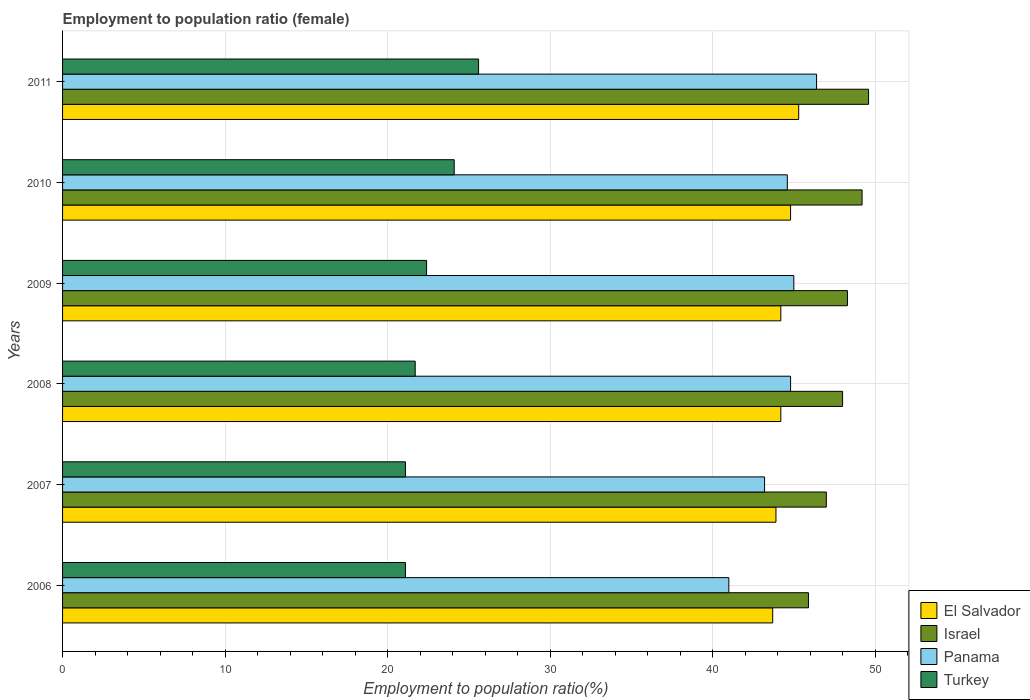How many different coloured bars are there?
Your answer should be compact. 4. Are the number of bars per tick equal to the number of legend labels?
Offer a terse response. Yes. Are the number of bars on each tick of the Y-axis equal?
Your answer should be compact. Yes. How many bars are there on the 4th tick from the top?
Offer a very short reply. 4. How many bars are there on the 3rd tick from the bottom?
Your response must be concise. 4. What is the label of the 2nd group of bars from the top?
Ensure brevity in your answer.  2010. What is the employment to population ratio in El Salvador in 2010?
Make the answer very short. 44.8. Across all years, what is the maximum employment to population ratio in Israel?
Give a very brief answer. 49.6. Across all years, what is the minimum employment to population ratio in El Salvador?
Offer a very short reply. 43.7. In which year was the employment to population ratio in Turkey maximum?
Your response must be concise. 2011. In which year was the employment to population ratio in Turkey minimum?
Offer a very short reply. 2006. What is the total employment to population ratio in El Salvador in the graph?
Offer a very short reply. 266.1. What is the difference between the employment to population ratio in El Salvador in 2006 and that in 2010?
Offer a very short reply. -1.1. What is the difference between the employment to population ratio in El Salvador in 2006 and the employment to population ratio in Turkey in 2010?
Your answer should be very brief. 19.6. What is the average employment to population ratio in Panama per year?
Keep it short and to the point. 44.17. In the year 2011, what is the difference between the employment to population ratio in Turkey and employment to population ratio in El Salvador?
Offer a terse response. -19.7. In how many years, is the employment to population ratio in El Salvador greater than 10 %?
Provide a short and direct response. 6. What is the ratio of the employment to population ratio in Israel in 2006 to that in 2008?
Provide a succinct answer. 0.96. Is the difference between the employment to population ratio in Turkey in 2009 and 2011 greater than the difference between the employment to population ratio in El Salvador in 2009 and 2011?
Give a very brief answer. No. What is the difference between the highest and the lowest employment to population ratio in Panama?
Your answer should be compact. 5.4. Is it the case that in every year, the sum of the employment to population ratio in El Salvador and employment to population ratio in Turkey is greater than the sum of employment to population ratio in Israel and employment to population ratio in Panama?
Offer a very short reply. No. How many bars are there?
Your response must be concise. 24. Are all the bars in the graph horizontal?
Give a very brief answer. Yes. How many years are there in the graph?
Your answer should be very brief. 6. What is the difference between two consecutive major ticks on the X-axis?
Your answer should be compact. 10. How many legend labels are there?
Your answer should be very brief. 4. How are the legend labels stacked?
Provide a succinct answer. Vertical. What is the title of the graph?
Your answer should be very brief. Employment to population ratio (female). What is the Employment to population ratio(%) in El Salvador in 2006?
Your answer should be compact. 43.7. What is the Employment to population ratio(%) in Israel in 2006?
Your answer should be compact. 45.9. What is the Employment to population ratio(%) in Turkey in 2006?
Provide a short and direct response. 21.1. What is the Employment to population ratio(%) of El Salvador in 2007?
Make the answer very short. 43.9. What is the Employment to population ratio(%) in Israel in 2007?
Keep it short and to the point. 47. What is the Employment to population ratio(%) of Panama in 2007?
Your answer should be very brief. 43.2. What is the Employment to population ratio(%) in Turkey in 2007?
Your answer should be very brief. 21.1. What is the Employment to population ratio(%) of El Salvador in 2008?
Make the answer very short. 44.2. What is the Employment to population ratio(%) in Israel in 2008?
Offer a very short reply. 48. What is the Employment to population ratio(%) in Panama in 2008?
Keep it short and to the point. 44.8. What is the Employment to population ratio(%) of Turkey in 2008?
Keep it short and to the point. 21.7. What is the Employment to population ratio(%) of El Salvador in 2009?
Your answer should be compact. 44.2. What is the Employment to population ratio(%) in Israel in 2009?
Provide a short and direct response. 48.3. What is the Employment to population ratio(%) in Turkey in 2009?
Give a very brief answer. 22.4. What is the Employment to population ratio(%) of El Salvador in 2010?
Offer a very short reply. 44.8. What is the Employment to population ratio(%) of Israel in 2010?
Offer a very short reply. 49.2. What is the Employment to population ratio(%) of Panama in 2010?
Offer a very short reply. 44.6. What is the Employment to population ratio(%) in Turkey in 2010?
Make the answer very short. 24.1. What is the Employment to population ratio(%) of El Salvador in 2011?
Provide a short and direct response. 45.3. What is the Employment to population ratio(%) of Israel in 2011?
Keep it short and to the point. 49.6. What is the Employment to population ratio(%) of Panama in 2011?
Ensure brevity in your answer.  46.4. What is the Employment to population ratio(%) in Turkey in 2011?
Keep it short and to the point. 25.6. Across all years, what is the maximum Employment to population ratio(%) of El Salvador?
Your response must be concise. 45.3. Across all years, what is the maximum Employment to population ratio(%) of Israel?
Offer a very short reply. 49.6. Across all years, what is the maximum Employment to population ratio(%) of Panama?
Provide a short and direct response. 46.4. Across all years, what is the maximum Employment to population ratio(%) in Turkey?
Offer a terse response. 25.6. Across all years, what is the minimum Employment to population ratio(%) of El Salvador?
Provide a succinct answer. 43.7. Across all years, what is the minimum Employment to population ratio(%) in Israel?
Provide a short and direct response. 45.9. Across all years, what is the minimum Employment to population ratio(%) of Panama?
Provide a succinct answer. 41. Across all years, what is the minimum Employment to population ratio(%) of Turkey?
Your answer should be compact. 21.1. What is the total Employment to population ratio(%) of El Salvador in the graph?
Offer a terse response. 266.1. What is the total Employment to population ratio(%) of Israel in the graph?
Offer a terse response. 288. What is the total Employment to population ratio(%) in Panama in the graph?
Keep it short and to the point. 265. What is the total Employment to population ratio(%) in Turkey in the graph?
Make the answer very short. 136. What is the difference between the Employment to population ratio(%) in Israel in 2006 and that in 2007?
Offer a terse response. -1.1. What is the difference between the Employment to population ratio(%) in El Salvador in 2006 and that in 2008?
Offer a very short reply. -0.5. What is the difference between the Employment to population ratio(%) in Israel in 2006 and that in 2008?
Your answer should be compact. -2.1. What is the difference between the Employment to population ratio(%) in Israel in 2006 and that in 2009?
Provide a succinct answer. -2.4. What is the difference between the Employment to population ratio(%) in El Salvador in 2006 and that in 2010?
Provide a short and direct response. -1.1. What is the difference between the Employment to population ratio(%) in Israel in 2006 and that in 2010?
Your answer should be very brief. -3.3. What is the difference between the Employment to population ratio(%) in El Salvador in 2006 and that in 2011?
Your answer should be very brief. -1.6. What is the difference between the Employment to population ratio(%) in Panama in 2006 and that in 2011?
Keep it short and to the point. -5.4. What is the difference between the Employment to population ratio(%) in El Salvador in 2007 and that in 2008?
Offer a very short reply. -0.3. What is the difference between the Employment to population ratio(%) in Israel in 2007 and that in 2009?
Provide a succinct answer. -1.3. What is the difference between the Employment to population ratio(%) in Panama in 2007 and that in 2009?
Offer a terse response. -1.8. What is the difference between the Employment to population ratio(%) of Turkey in 2007 and that in 2009?
Ensure brevity in your answer.  -1.3. What is the difference between the Employment to population ratio(%) of El Salvador in 2007 and that in 2010?
Your answer should be compact. -0.9. What is the difference between the Employment to population ratio(%) in Israel in 2007 and that in 2010?
Offer a very short reply. -2.2. What is the difference between the Employment to population ratio(%) of Turkey in 2007 and that in 2010?
Keep it short and to the point. -3. What is the difference between the Employment to population ratio(%) of El Salvador in 2007 and that in 2011?
Your answer should be very brief. -1.4. What is the difference between the Employment to population ratio(%) of Turkey in 2007 and that in 2011?
Your answer should be compact. -4.5. What is the difference between the Employment to population ratio(%) of El Salvador in 2008 and that in 2009?
Offer a very short reply. 0. What is the difference between the Employment to population ratio(%) of Israel in 2008 and that in 2009?
Your answer should be very brief. -0.3. What is the difference between the Employment to population ratio(%) in Panama in 2008 and that in 2009?
Your response must be concise. -0.2. What is the difference between the Employment to population ratio(%) of Turkey in 2008 and that in 2009?
Provide a succinct answer. -0.7. What is the difference between the Employment to population ratio(%) in El Salvador in 2008 and that in 2010?
Give a very brief answer. -0.6. What is the difference between the Employment to population ratio(%) in Panama in 2008 and that in 2010?
Your answer should be compact. 0.2. What is the difference between the Employment to population ratio(%) in Turkey in 2008 and that in 2010?
Keep it short and to the point. -2.4. What is the difference between the Employment to population ratio(%) in Israel in 2008 and that in 2011?
Make the answer very short. -1.6. What is the difference between the Employment to population ratio(%) of Panama in 2008 and that in 2011?
Your answer should be very brief. -1.6. What is the difference between the Employment to population ratio(%) in Turkey in 2008 and that in 2011?
Make the answer very short. -3.9. What is the difference between the Employment to population ratio(%) of El Salvador in 2009 and that in 2010?
Give a very brief answer. -0.6. What is the difference between the Employment to population ratio(%) of El Salvador in 2009 and that in 2011?
Ensure brevity in your answer.  -1.1. What is the difference between the Employment to population ratio(%) of Panama in 2009 and that in 2011?
Give a very brief answer. -1.4. What is the difference between the Employment to population ratio(%) of Turkey in 2010 and that in 2011?
Offer a very short reply. -1.5. What is the difference between the Employment to population ratio(%) in El Salvador in 2006 and the Employment to population ratio(%) in Panama in 2007?
Ensure brevity in your answer.  0.5. What is the difference between the Employment to population ratio(%) in El Salvador in 2006 and the Employment to population ratio(%) in Turkey in 2007?
Offer a very short reply. 22.6. What is the difference between the Employment to population ratio(%) in Israel in 2006 and the Employment to population ratio(%) in Panama in 2007?
Provide a short and direct response. 2.7. What is the difference between the Employment to population ratio(%) of Israel in 2006 and the Employment to population ratio(%) of Turkey in 2007?
Offer a terse response. 24.8. What is the difference between the Employment to population ratio(%) of Panama in 2006 and the Employment to population ratio(%) of Turkey in 2007?
Your answer should be very brief. 19.9. What is the difference between the Employment to population ratio(%) of El Salvador in 2006 and the Employment to population ratio(%) of Panama in 2008?
Give a very brief answer. -1.1. What is the difference between the Employment to population ratio(%) of Israel in 2006 and the Employment to population ratio(%) of Panama in 2008?
Keep it short and to the point. 1.1. What is the difference between the Employment to population ratio(%) in Israel in 2006 and the Employment to population ratio(%) in Turkey in 2008?
Your response must be concise. 24.2. What is the difference between the Employment to population ratio(%) of Panama in 2006 and the Employment to population ratio(%) of Turkey in 2008?
Make the answer very short. 19.3. What is the difference between the Employment to population ratio(%) of El Salvador in 2006 and the Employment to population ratio(%) of Panama in 2009?
Your response must be concise. -1.3. What is the difference between the Employment to population ratio(%) in El Salvador in 2006 and the Employment to population ratio(%) in Turkey in 2009?
Your response must be concise. 21.3. What is the difference between the Employment to population ratio(%) in Israel in 2006 and the Employment to population ratio(%) in Panama in 2009?
Make the answer very short. 0.9. What is the difference between the Employment to population ratio(%) of El Salvador in 2006 and the Employment to population ratio(%) of Turkey in 2010?
Make the answer very short. 19.6. What is the difference between the Employment to population ratio(%) of Israel in 2006 and the Employment to population ratio(%) of Turkey in 2010?
Provide a short and direct response. 21.8. What is the difference between the Employment to population ratio(%) of Panama in 2006 and the Employment to population ratio(%) of Turkey in 2010?
Your response must be concise. 16.9. What is the difference between the Employment to population ratio(%) in El Salvador in 2006 and the Employment to population ratio(%) in Panama in 2011?
Offer a terse response. -2.7. What is the difference between the Employment to population ratio(%) in Israel in 2006 and the Employment to population ratio(%) in Turkey in 2011?
Make the answer very short. 20.3. What is the difference between the Employment to population ratio(%) of El Salvador in 2007 and the Employment to population ratio(%) of Israel in 2008?
Make the answer very short. -4.1. What is the difference between the Employment to population ratio(%) in Israel in 2007 and the Employment to population ratio(%) in Turkey in 2008?
Your response must be concise. 25.3. What is the difference between the Employment to population ratio(%) in Panama in 2007 and the Employment to population ratio(%) in Turkey in 2008?
Provide a short and direct response. 21.5. What is the difference between the Employment to population ratio(%) in El Salvador in 2007 and the Employment to population ratio(%) in Israel in 2009?
Offer a terse response. -4.4. What is the difference between the Employment to population ratio(%) of El Salvador in 2007 and the Employment to population ratio(%) of Panama in 2009?
Ensure brevity in your answer.  -1.1. What is the difference between the Employment to population ratio(%) in El Salvador in 2007 and the Employment to population ratio(%) in Turkey in 2009?
Your answer should be compact. 21.5. What is the difference between the Employment to population ratio(%) in Israel in 2007 and the Employment to population ratio(%) in Panama in 2009?
Ensure brevity in your answer.  2. What is the difference between the Employment to population ratio(%) in Israel in 2007 and the Employment to population ratio(%) in Turkey in 2009?
Ensure brevity in your answer.  24.6. What is the difference between the Employment to population ratio(%) of Panama in 2007 and the Employment to population ratio(%) of Turkey in 2009?
Make the answer very short. 20.8. What is the difference between the Employment to population ratio(%) of El Salvador in 2007 and the Employment to population ratio(%) of Panama in 2010?
Your answer should be very brief. -0.7. What is the difference between the Employment to population ratio(%) of El Salvador in 2007 and the Employment to population ratio(%) of Turkey in 2010?
Provide a short and direct response. 19.8. What is the difference between the Employment to population ratio(%) of Israel in 2007 and the Employment to population ratio(%) of Turkey in 2010?
Offer a terse response. 22.9. What is the difference between the Employment to population ratio(%) in El Salvador in 2007 and the Employment to population ratio(%) in Israel in 2011?
Give a very brief answer. -5.7. What is the difference between the Employment to population ratio(%) of El Salvador in 2007 and the Employment to population ratio(%) of Turkey in 2011?
Offer a very short reply. 18.3. What is the difference between the Employment to population ratio(%) in Israel in 2007 and the Employment to population ratio(%) in Panama in 2011?
Provide a succinct answer. 0.6. What is the difference between the Employment to population ratio(%) in Israel in 2007 and the Employment to population ratio(%) in Turkey in 2011?
Ensure brevity in your answer.  21.4. What is the difference between the Employment to population ratio(%) in Panama in 2007 and the Employment to population ratio(%) in Turkey in 2011?
Provide a succinct answer. 17.6. What is the difference between the Employment to population ratio(%) in El Salvador in 2008 and the Employment to population ratio(%) in Panama in 2009?
Ensure brevity in your answer.  -0.8. What is the difference between the Employment to population ratio(%) of El Salvador in 2008 and the Employment to population ratio(%) of Turkey in 2009?
Your answer should be compact. 21.8. What is the difference between the Employment to population ratio(%) in Israel in 2008 and the Employment to population ratio(%) in Turkey in 2009?
Give a very brief answer. 25.6. What is the difference between the Employment to population ratio(%) in Panama in 2008 and the Employment to population ratio(%) in Turkey in 2009?
Offer a terse response. 22.4. What is the difference between the Employment to population ratio(%) of El Salvador in 2008 and the Employment to population ratio(%) of Panama in 2010?
Your answer should be compact. -0.4. What is the difference between the Employment to population ratio(%) in El Salvador in 2008 and the Employment to population ratio(%) in Turkey in 2010?
Your response must be concise. 20.1. What is the difference between the Employment to population ratio(%) in Israel in 2008 and the Employment to population ratio(%) in Panama in 2010?
Provide a succinct answer. 3.4. What is the difference between the Employment to population ratio(%) of Israel in 2008 and the Employment to population ratio(%) of Turkey in 2010?
Keep it short and to the point. 23.9. What is the difference between the Employment to population ratio(%) of Panama in 2008 and the Employment to population ratio(%) of Turkey in 2010?
Give a very brief answer. 20.7. What is the difference between the Employment to population ratio(%) in El Salvador in 2008 and the Employment to population ratio(%) in Turkey in 2011?
Your answer should be very brief. 18.6. What is the difference between the Employment to population ratio(%) in Israel in 2008 and the Employment to population ratio(%) in Turkey in 2011?
Your answer should be very brief. 22.4. What is the difference between the Employment to population ratio(%) in El Salvador in 2009 and the Employment to population ratio(%) in Israel in 2010?
Your response must be concise. -5. What is the difference between the Employment to population ratio(%) of El Salvador in 2009 and the Employment to population ratio(%) of Panama in 2010?
Provide a short and direct response. -0.4. What is the difference between the Employment to population ratio(%) of El Salvador in 2009 and the Employment to population ratio(%) of Turkey in 2010?
Provide a succinct answer. 20.1. What is the difference between the Employment to population ratio(%) of Israel in 2009 and the Employment to population ratio(%) of Panama in 2010?
Keep it short and to the point. 3.7. What is the difference between the Employment to population ratio(%) in Israel in 2009 and the Employment to population ratio(%) in Turkey in 2010?
Your answer should be compact. 24.2. What is the difference between the Employment to population ratio(%) of Panama in 2009 and the Employment to population ratio(%) of Turkey in 2010?
Make the answer very short. 20.9. What is the difference between the Employment to population ratio(%) in El Salvador in 2009 and the Employment to population ratio(%) in Israel in 2011?
Ensure brevity in your answer.  -5.4. What is the difference between the Employment to population ratio(%) of El Salvador in 2009 and the Employment to population ratio(%) of Panama in 2011?
Your response must be concise. -2.2. What is the difference between the Employment to population ratio(%) in Israel in 2009 and the Employment to population ratio(%) in Panama in 2011?
Your response must be concise. 1.9. What is the difference between the Employment to population ratio(%) of Israel in 2009 and the Employment to population ratio(%) of Turkey in 2011?
Offer a very short reply. 22.7. What is the difference between the Employment to population ratio(%) in Panama in 2009 and the Employment to population ratio(%) in Turkey in 2011?
Your answer should be very brief. 19.4. What is the difference between the Employment to population ratio(%) in El Salvador in 2010 and the Employment to population ratio(%) in Israel in 2011?
Make the answer very short. -4.8. What is the difference between the Employment to population ratio(%) in El Salvador in 2010 and the Employment to population ratio(%) in Panama in 2011?
Make the answer very short. -1.6. What is the difference between the Employment to population ratio(%) in Israel in 2010 and the Employment to population ratio(%) in Panama in 2011?
Ensure brevity in your answer.  2.8. What is the difference between the Employment to population ratio(%) of Israel in 2010 and the Employment to population ratio(%) of Turkey in 2011?
Your response must be concise. 23.6. What is the average Employment to population ratio(%) in El Salvador per year?
Keep it short and to the point. 44.35. What is the average Employment to population ratio(%) in Israel per year?
Ensure brevity in your answer.  48. What is the average Employment to population ratio(%) of Panama per year?
Offer a very short reply. 44.17. What is the average Employment to population ratio(%) of Turkey per year?
Keep it short and to the point. 22.67. In the year 2006, what is the difference between the Employment to population ratio(%) of El Salvador and Employment to population ratio(%) of Israel?
Your answer should be very brief. -2.2. In the year 2006, what is the difference between the Employment to population ratio(%) of El Salvador and Employment to population ratio(%) of Panama?
Ensure brevity in your answer.  2.7. In the year 2006, what is the difference between the Employment to population ratio(%) in El Salvador and Employment to population ratio(%) in Turkey?
Keep it short and to the point. 22.6. In the year 2006, what is the difference between the Employment to population ratio(%) of Israel and Employment to population ratio(%) of Panama?
Ensure brevity in your answer.  4.9. In the year 2006, what is the difference between the Employment to population ratio(%) in Israel and Employment to population ratio(%) in Turkey?
Make the answer very short. 24.8. In the year 2007, what is the difference between the Employment to population ratio(%) of El Salvador and Employment to population ratio(%) of Panama?
Ensure brevity in your answer.  0.7. In the year 2007, what is the difference between the Employment to population ratio(%) of El Salvador and Employment to population ratio(%) of Turkey?
Your answer should be very brief. 22.8. In the year 2007, what is the difference between the Employment to population ratio(%) in Israel and Employment to population ratio(%) in Panama?
Your answer should be compact. 3.8. In the year 2007, what is the difference between the Employment to population ratio(%) of Israel and Employment to population ratio(%) of Turkey?
Give a very brief answer. 25.9. In the year 2007, what is the difference between the Employment to population ratio(%) in Panama and Employment to population ratio(%) in Turkey?
Keep it short and to the point. 22.1. In the year 2008, what is the difference between the Employment to population ratio(%) in El Salvador and Employment to population ratio(%) in Israel?
Your response must be concise. -3.8. In the year 2008, what is the difference between the Employment to population ratio(%) of Israel and Employment to population ratio(%) of Panama?
Give a very brief answer. 3.2. In the year 2008, what is the difference between the Employment to population ratio(%) in Israel and Employment to population ratio(%) in Turkey?
Offer a very short reply. 26.3. In the year 2008, what is the difference between the Employment to population ratio(%) in Panama and Employment to population ratio(%) in Turkey?
Your response must be concise. 23.1. In the year 2009, what is the difference between the Employment to population ratio(%) of El Salvador and Employment to population ratio(%) of Israel?
Offer a very short reply. -4.1. In the year 2009, what is the difference between the Employment to population ratio(%) of El Salvador and Employment to population ratio(%) of Panama?
Your answer should be compact. -0.8. In the year 2009, what is the difference between the Employment to population ratio(%) of El Salvador and Employment to population ratio(%) of Turkey?
Your answer should be very brief. 21.8. In the year 2009, what is the difference between the Employment to population ratio(%) in Israel and Employment to population ratio(%) in Panama?
Offer a terse response. 3.3. In the year 2009, what is the difference between the Employment to population ratio(%) in Israel and Employment to population ratio(%) in Turkey?
Your answer should be very brief. 25.9. In the year 2009, what is the difference between the Employment to population ratio(%) of Panama and Employment to population ratio(%) of Turkey?
Ensure brevity in your answer.  22.6. In the year 2010, what is the difference between the Employment to population ratio(%) in El Salvador and Employment to population ratio(%) in Panama?
Offer a terse response. 0.2. In the year 2010, what is the difference between the Employment to population ratio(%) in El Salvador and Employment to population ratio(%) in Turkey?
Your answer should be compact. 20.7. In the year 2010, what is the difference between the Employment to population ratio(%) in Israel and Employment to population ratio(%) in Turkey?
Ensure brevity in your answer.  25.1. In the year 2011, what is the difference between the Employment to population ratio(%) in El Salvador and Employment to population ratio(%) in Israel?
Your answer should be very brief. -4.3. In the year 2011, what is the difference between the Employment to population ratio(%) in El Salvador and Employment to population ratio(%) in Turkey?
Provide a short and direct response. 19.7. In the year 2011, what is the difference between the Employment to population ratio(%) of Israel and Employment to population ratio(%) of Panama?
Offer a terse response. 3.2. In the year 2011, what is the difference between the Employment to population ratio(%) of Israel and Employment to population ratio(%) of Turkey?
Give a very brief answer. 24. In the year 2011, what is the difference between the Employment to population ratio(%) of Panama and Employment to population ratio(%) of Turkey?
Offer a terse response. 20.8. What is the ratio of the Employment to population ratio(%) in Israel in 2006 to that in 2007?
Provide a short and direct response. 0.98. What is the ratio of the Employment to population ratio(%) of Panama in 2006 to that in 2007?
Provide a succinct answer. 0.95. What is the ratio of the Employment to population ratio(%) of Turkey in 2006 to that in 2007?
Provide a succinct answer. 1. What is the ratio of the Employment to population ratio(%) of El Salvador in 2006 to that in 2008?
Make the answer very short. 0.99. What is the ratio of the Employment to population ratio(%) of Israel in 2006 to that in 2008?
Provide a succinct answer. 0.96. What is the ratio of the Employment to population ratio(%) in Panama in 2006 to that in 2008?
Offer a very short reply. 0.92. What is the ratio of the Employment to population ratio(%) of Turkey in 2006 to that in 2008?
Give a very brief answer. 0.97. What is the ratio of the Employment to population ratio(%) in El Salvador in 2006 to that in 2009?
Your answer should be compact. 0.99. What is the ratio of the Employment to population ratio(%) of Israel in 2006 to that in 2009?
Make the answer very short. 0.95. What is the ratio of the Employment to population ratio(%) in Panama in 2006 to that in 2009?
Your answer should be very brief. 0.91. What is the ratio of the Employment to population ratio(%) of Turkey in 2006 to that in 2009?
Your response must be concise. 0.94. What is the ratio of the Employment to population ratio(%) in El Salvador in 2006 to that in 2010?
Your answer should be very brief. 0.98. What is the ratio of the Employment to population ratio(%) of Israel in 2006 to that in 2010?
Ensure brevity in your answer.  0.93. What is the ratio of the Employment to population ratio(%) in Panama in 2006 to that in 2010?
Your response must be concise. 0.92. What is the ratio of the Employment to population ratio(%) in Turkey in 2006 to that in 2010?
Provide a short and direct response. 0.88. What is the ratio of the Employment to population ratio(%) in El Salvador in 2006 to that in 2011?
Make the answer very short. 0.96. What is the ratio of the Employment to population ratio(%) of Israel in 2006 to that in 2011?
Your answer should be compact. 0.93. What is the ratio of the Employment to population ratio(%) of Panama in 2006 to that in 2011?
Make the answer very short. 0.88. What is the ratio of the Employment to population ratio(%) of Turkey in 2006 to that in 2011?
Offer a terse response. 0.82. What is the ratio of the Employment to population ratio(%) of El Salvador in 2007 to that in 2008?
Offer a terse response. 0.99. What is the ratio of the Employment to population ratio(%) of Israel in 2007 to that in 2008?
Your answer should be compact. 0.98. What is the ratio of the Employment to population ratio(%) in Panama in 2007 to that in 2008?
Provide a short and direct response. 0.96. What is the ratio of the Employment to population ratio(%) in Turkey in 2007 to that in 2008?
Give a very brief answer. 0.97. What is the ratio of the Employment to population ratio(%) in Israel in 2007 to that in 2009?
Make the answer very short. 0.97. What is the ratio of the Employment to population ratio(%) of Panama in 2007 to that in 2009?
Offer a terse response. 0.96. What is the ratio of the Employment to population ratio(%) of Turkey in 2007 to that in 2009?
Ensure brevity in your answer.  0.94. What is the ratio of the Employment to population ratio(%) of El Salvador in 2007 to that in 2010?
Keep it short and to the point. 0.98. What is the ratio of the Employment to population ratio(%) of Israel in 2007 to that in 2010?
Your response must be concise. 0.96. What is the ratio of the Employment to population ratio(%) of Panama in 2007 to that in 2010?
Provide a short and direct response. 0.97. What is the ratio of the Employment to population ratio(%) in Turkey in 2007 to that in 2010?
Offer a terse response. 0.88. What is the ratio of the Employment to population ratio(%) of El Salvador in 2007 to that in 2011?
Your answer should be very brief. 0.97. What is the ratio of the Employment to population ratio(%) of Israel in 2007 to that in 2011?
Offer a very short reply. 0.95. What is the ratio of the Employment to population ratio(%) of Turkey in 2007 to that in 2011?
Keep it short and to the point. 0.82. What is the ratio of the Employment to population ratio(%) of El Salvador in 2008 to that in 2009?
Your answer should be very brief. 1. What is the ratio of the Employment to population ratio(%) of Turkey in 2008 to that in 2009?
Keep it short and to the point. 0.97. What is the ratio of the Employment to population ratio(%) of El Salvador in 2008 to that in 2010?
Make the answer very short. 0.99. What is the ratio of the Employment to population ratio(%) in Israel in 2008 to that in 2010?
Your answer should be compact. 0.98. What is the ratio of the Employment to population ratio(%) in Turkey in 2008 to that in 2010?
Your response must be concise. 0.9. What is the ratio of the Employment to population ratio(%) in El Salvador in 2008 to that in 2011?
Make the answer very short. 0.98. What is the ratio of the Employment to population ratio(%) of Israel in 2008 to that in 2011?
Ensure brevity in your answer.  0.97. What is the ratio of the Employment to population ratio(%) in Panama in 2008 to that in 2011?
Offer a terse response. 0.97. What is the ratio of the Employment to population ratio(%) of Turkey in 2008 to that in 2011?
Offer a terse response. 0.85. What is the ratio of the Employment to population ratio(%) of El Salvador in 2009 to that in 2010?
Make the answer very short. 0.99. What is the ratio of the Employment to population ratio(%) in Israel in 2009 to that in 2010?
Make the answer very short. 0.98. What is the ratio of the Employment to population ratio(%) of Panama in 2009 to that in 2010?
Offer a terse response. 1.01. What is the ratio of the Employment to population ratio(%) in Turkey in 2009 to that in 2010?
Ensure brevity in your answer.  0.93. What is the ratio of the Employment to population ratio(%) in El Salvador in 2009 to that in 2011?
Give a very brief answer. 0.98. What is the ratio of the Employment to population ratio(%) of Israel in 2009 to that in 2011?
Keep it short and to the point. 0.97. What is the ratio of the Employment to population ratio(%) in Panama in 2009 to that in 2011?
Your answer should be compact. 0.97. What is the ratio of the Employment to population ratio(%) in Turkey in 2009 to that in 2011?
Make the answer very short. 0.88. What is the ratio of the Employment to population ratio(%) in El Salvador in 2010 to that in 2011?
Provide a succinct answer. 0.99. What is the ratio of the Employment to population ratio(%) in Israel in 2010 to that in 2011?
Your answer should be compact. 0.99. What is the ratio of the Employment to population ratio(%) in Panama in 2010 to that in 2011?
Offer a very short reply. 0.96. What is the ratio of the Employment to population ratio(%) of Turkey in 2010 to that in 2011?
Keep it short and to the point. 0.94. What is the difference between the highest and the second highest Employment to population ratio(%) of El Salvador?
Your answer should be very brief. 0.5. What is the difference between the highest and the lowest Employment to population ratio(%) of El Salvador?
Offer a very short reply. 1.6. What is the difference between the highest and the lowest Employment to population ratio(%) in Panama?
Your answer should be compact. 5.4. What is the difference between the highest and the lowest Employment to population ratio(%) in Turkey?
Your answer should be compact. 4.5. 